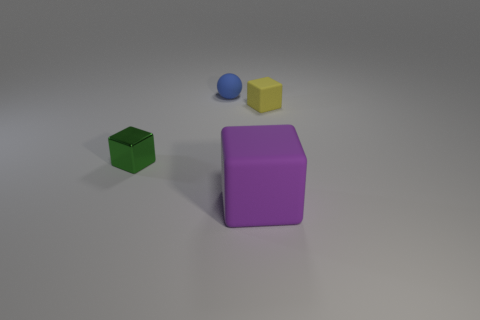Add 3 small blue spheres. How many objects exist? 7 Subtract all large matte cubes. How many cubes are left? 2 Subtract all purple blocks. How many blocks are left? 2 Subtract all balls. How many objects are left? 3 Subtract 1 balls. How many balls are left? 0 Subtract all small green objects. Subtract all big gray metallic spheres. How many objects are left? 3 Add 4 blue matte balls. How many blue matte balls are left? 5 Add 2 large rubber objects. How many large rubber objects exist? 3 Subtract 1 green blocks. How many objects are left? 3 Subtract all yellow balls. Subtract all blue cubes. How many balls are left? 1 